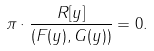<formula> <loc_0><loc_0><loc_500><loc_500>\pi \cdot \frac { R [ y ] } { ( F ( y ) , G ( y ) ) } = 0 .</formula> 